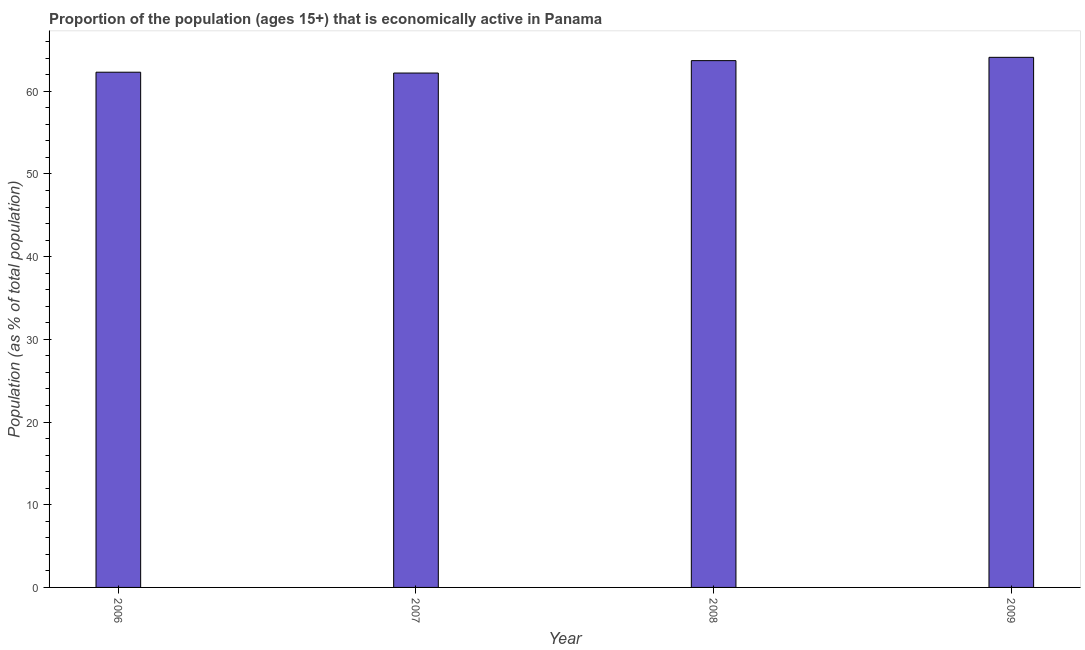Does the graph contain any zero values?
Your answer should be compact. No. Does the graph contain grids?
Provide a short and direct response. No. What is the title of the graph?
Offer a terse response. Proportion of the population (ages 15+) that is economically active in Panama. What is the label or title of the Y-axis?
Keep it short and to the point. Population (as % of total population). What is the percentage of economically active population in 2007?
Make the answer very short. 62.2. Across all years, what is the maximum percentage of economically active population?
Your response must be concise. 64.1. Across all years, what is the minimum percentage of economically active population?
Give a very brief answer. 62.2. What is the sum of the percentage of economically active population?
Offer a terse response. 252.3. What is the difference between the percentage of economically active population in 2008 and 2009?
Your response must be concise. -0.4. What is the average percentage of economically active population per year?
Give a very brief answer. 63.08. What is the median percentage of economically active population?
Your response must be concise. 63. Is the percentage of economically active population in 2006 less than that in 2008?
Your answer should be very brief. Yes. What is the difference between the highest and the lowest percentage of economically active population?
Your answer should be very brief. 1.9. Are the values on the major ticks of Y-axis written in scientific E-notation?
Make the answer very short. No. What is the Population (as % of total population) of 2006?
Your answer should be compact. 62.3. What is the Population (as % of total population) of 2007?
Provide a short and direct response. 62.2. What is the Population (as % of total population) in 2008?
Your response must be concise. 63.7. What is the Population (as % of total population) in 2009?
Ensure brevity in your answer.  64.1. What is the difference between the Population (as % of total population) in 2006 and 2007?
Offer a very short reply. 0.1. What is the difference between the Population (as % of total population) in 2007 and 2008?
Provide a succinct answer. -1.5. What is the ratio of the Population (as % of total population) in 2006 to that in 2007?
Give a very brief answer. 1. What is the ratio of the Population (as % of total population) in 2007 to that in 2008?
Keep it short and to the point. 0.98. 